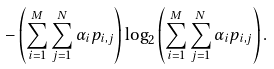<formula> <loc_0><loc_0><loc_500><loc_500>- \left ( \sum _ { i = 1 } ^ { M } \sum _ { j = 1 } ^ { N } \alpha _ { i } p _ { i , j } \right ) \log _ { 2 } \left ( \sum _ { i = 1 } ^ { M } \sum _ { j = 1 } ^ { N } \alpha _ { i } p _ { i , j } \right ) .</formula> 